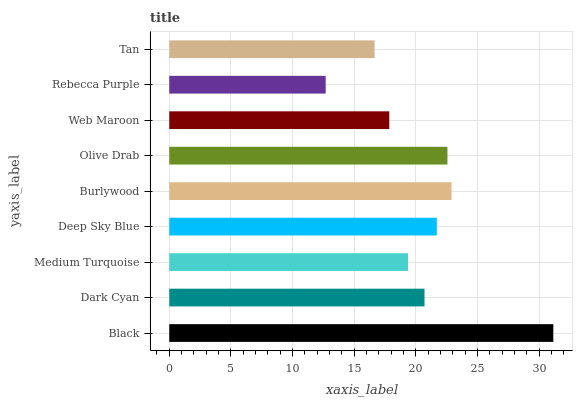Is Rebecca Purple the minimum?
Answer yes or no. Yes. Is Black the maximum?
Answer yes or no. Yes. Is Dark Cyan the minimum?
Answer yes or no. No. Is Dark Cyan the maximum?
Answer yes or no. No. Is Black greater than Dark Cyan?
Answer yes or no. Yes. Is Dark Cyan less than Black?
Answer yes or no. Yes. Is Dark Cyan greater than Black?
Answer yes or no. No. Is Black less than Dark Cyan?
Answer yes or no. No. Is Dark Cyan the high median?
Answer yes or no. Yes. Is Dark Cyan the low median?
Answer yes or no. Yes. Is Web Maroon the high median?
Answer yes or no. No. Is Rebecca Purple the low median?
Answer yes or no. No. 